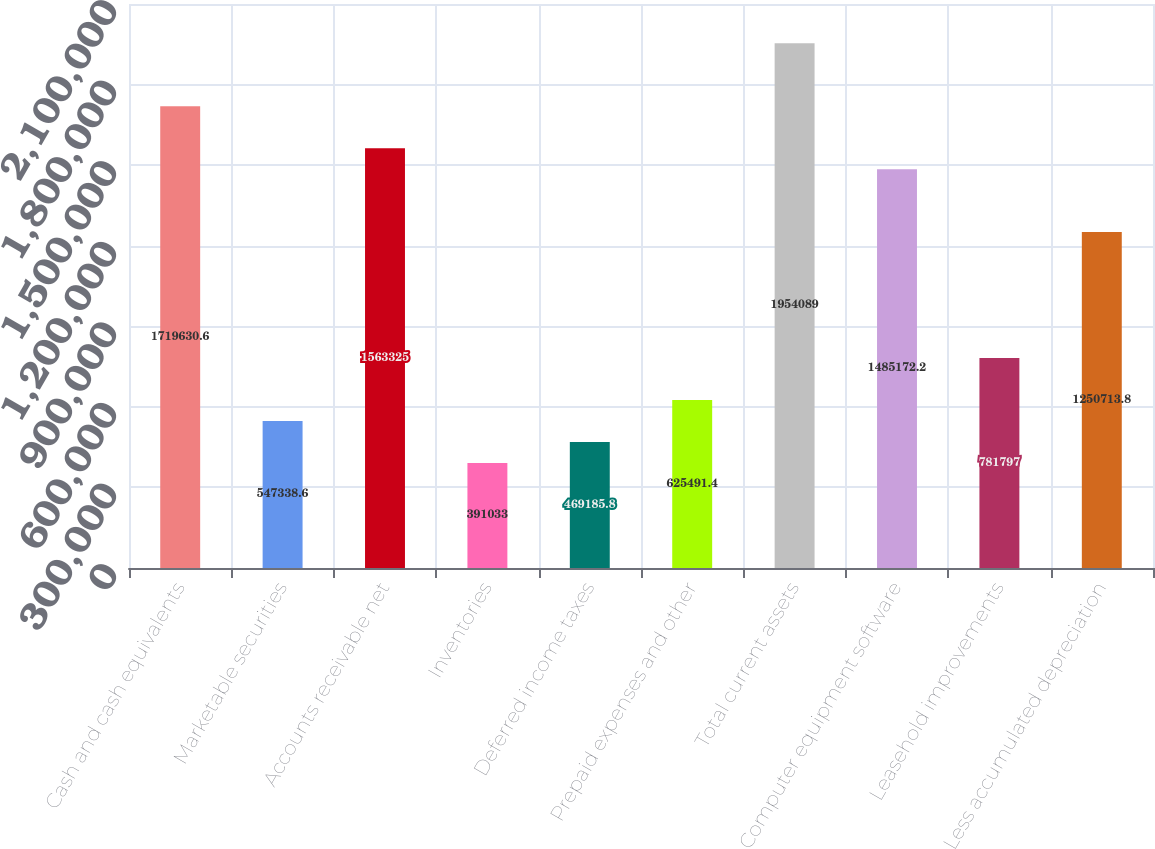<chart> <loc_0><loc_0><loc_500><loc_500><bar_chart><fcel>Cash and cash equivalents<fcel>Marketable securities<fcel>Accounts receivable net<fcel>Inventories<fcel>Deferred income taxes<fcel>Prepaid expenses and other<fcel>Total current assets<fcel>Computer equipment software<fcel>Leasehold improvements<fcel>Less accumulated depreciation<nl><fcel>1.71963e+06<fcel>547339<fcel>1.56332e+06<fcel>391033<fcel>469186<fcel>625491<fcel>1.95409e+06<fcel>1.48517e+06<fcel>781797<fcel>1.25071e+06<nl></chart> 